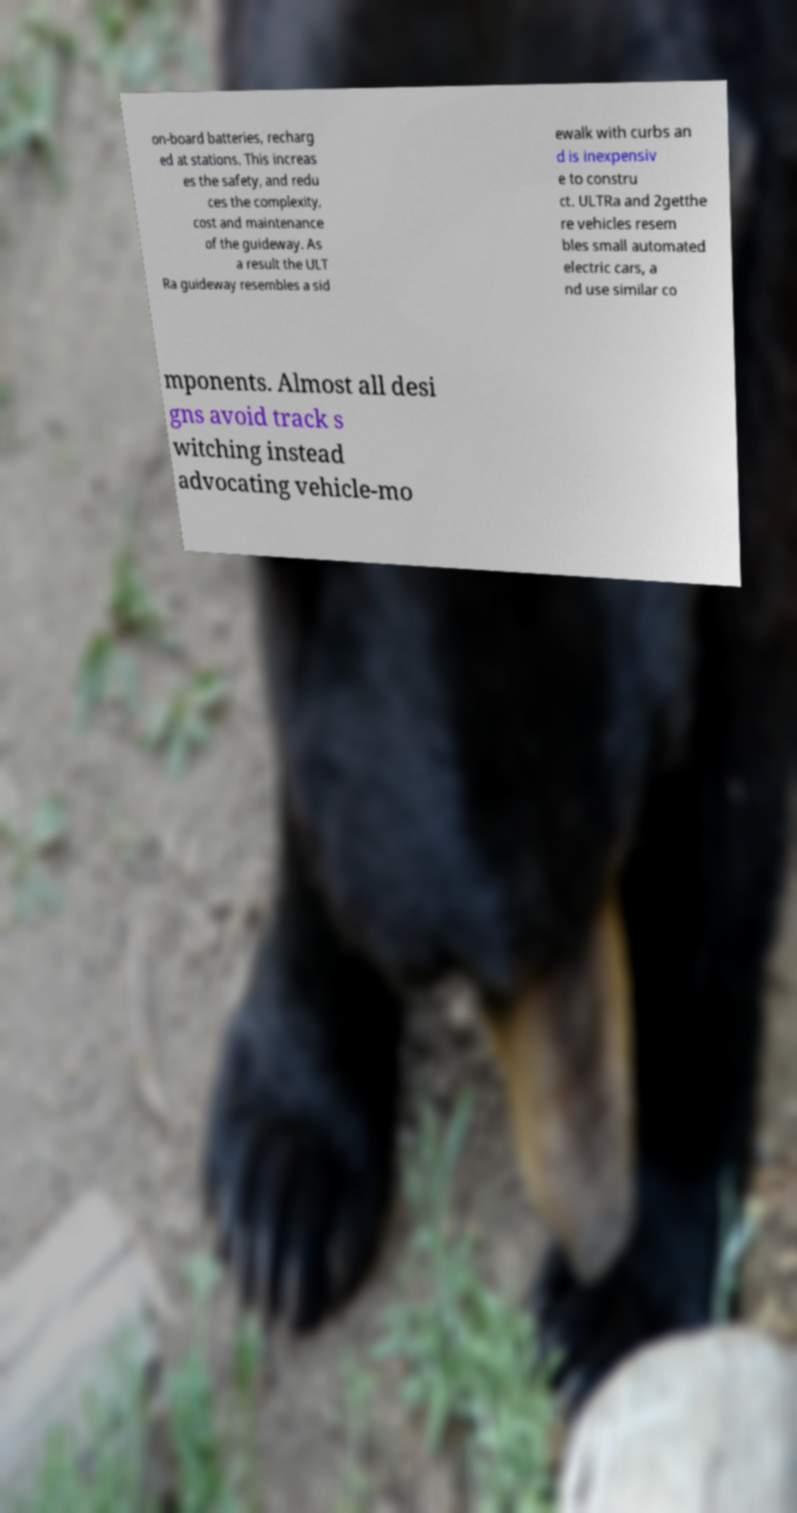I need the written content from this picture converted into text. Can you do that? on-board batteries, recharg ed at stations. This increas es the safety, and redu ces the complexity, cost and maintenance of the guideway. As a result the ULT Ra guideway resembles a sid ewalk with curbs an d is inexpensiv e to constru ct. ULTRa and 2getthe re vehicles resem bles small automated electric cars, a nd use similar co mponents. Almost all desi gns avoid track s witching instead advocating vehicle-mo 